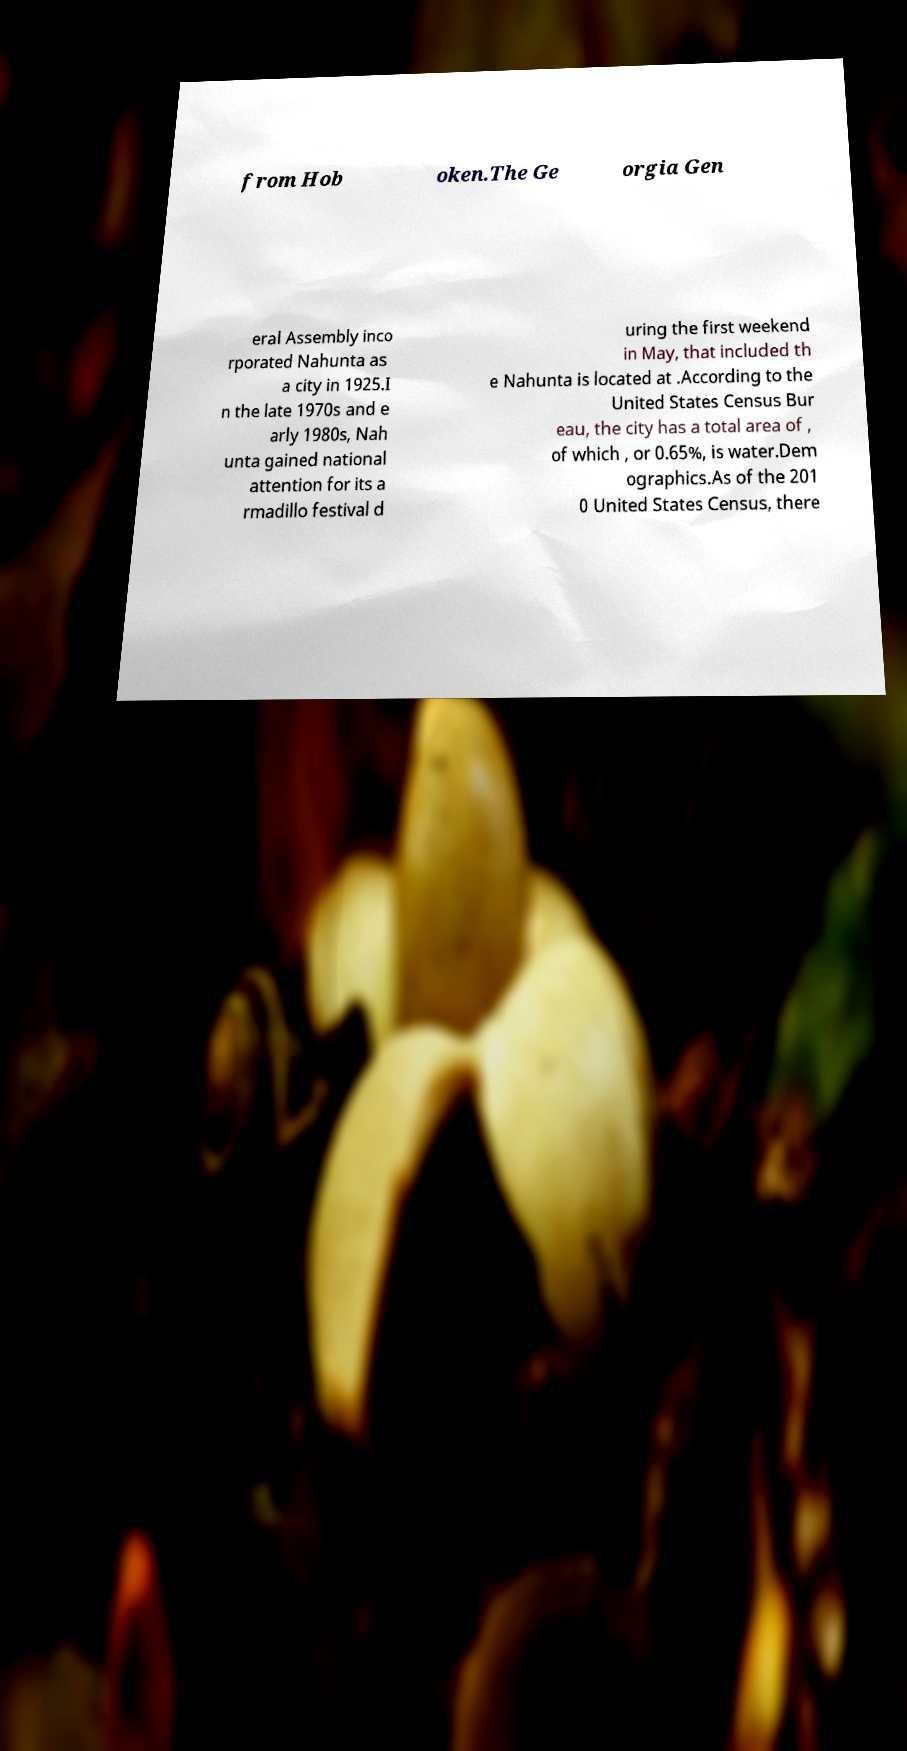For documentation purposes, I need the text within this image transcribed. Could you provide that? from Hob oken.The Ge orgia Gen eral Assembly inco rporated Nahunta as a city in 1925.I n the late 1970s and e arly 1980s, Nah unta gained national attention for its a rmadillo festival d uring the first weekend in May, that included th e Nahunta is located at .According to the United States Census Bur eau, the city has a total area of , of which , or 0.65%, is water.Dem ographics.As of the 201 0 United States Census, there 